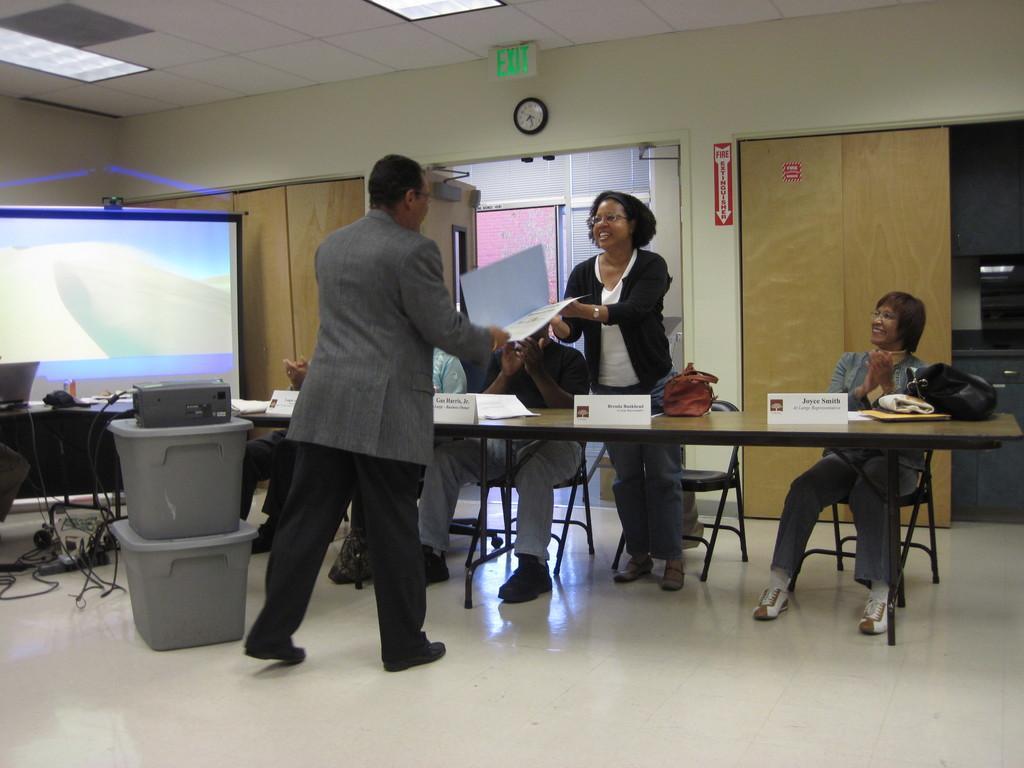In one or two sentences, can you explain what this image depicts? This picture is taken in the room, There is a floor in white color, There is a table in brown color, There are some people siting on the chairs, In the middle there is a man standing and receiving a book from woman, In the background there is a brown color door and a white color wall. 